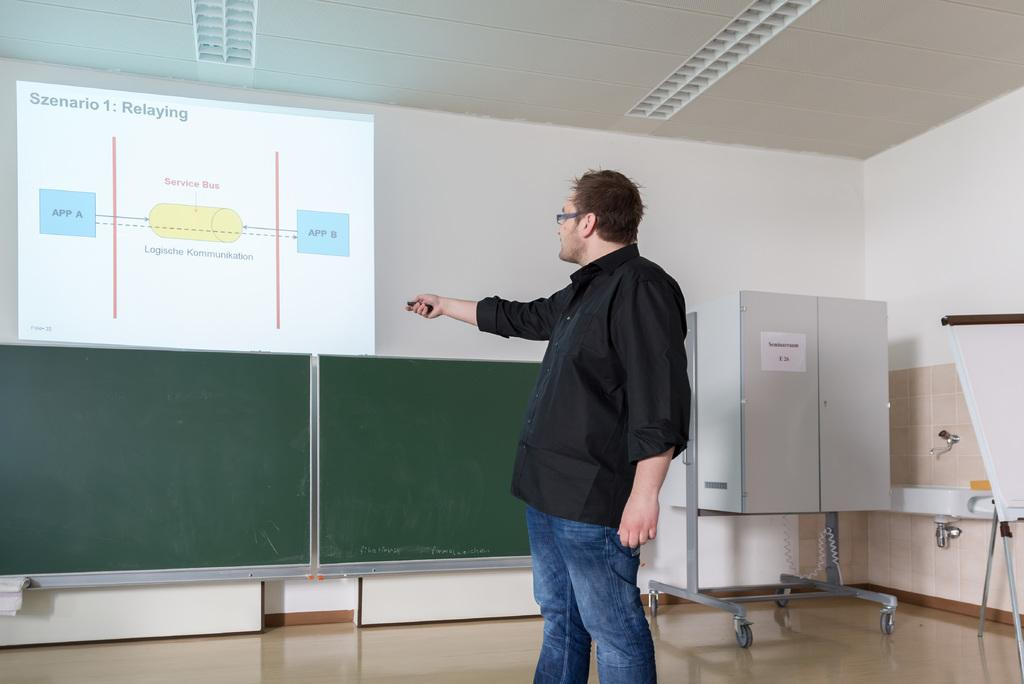<image>
Give a short and clear explanation of the subsequent image. A presentation on a wall that says "Szenario 1: Relaying" 